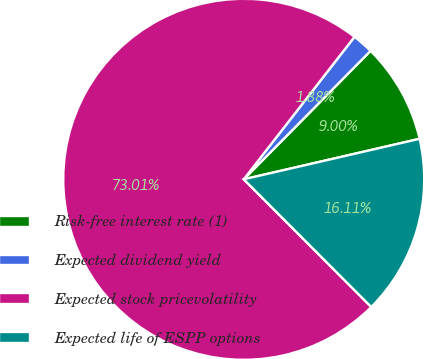Convert chart to OTSL. <chart><loc_0><loc_0><loc_500><loc_500><pie_chart><fcel>Risk-free interest rate (1)<fcel>Expected dividend yield<fcel>Expected stock pricevolatility<fcel>Expected life of ESPP options<nl><fcel>9.0%<fcel>1.88%<fcel>73.01%<fcel>16.11%<nl></chart> 